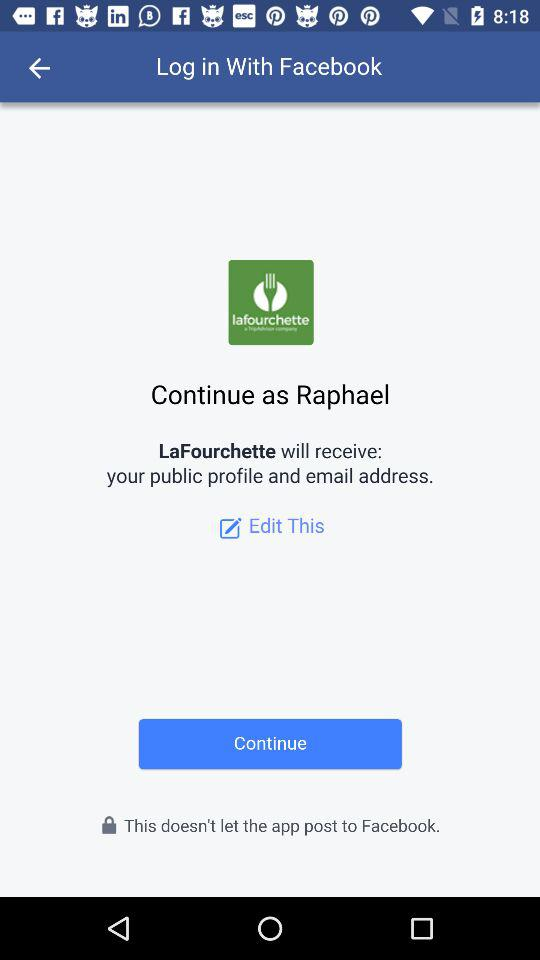What is the name of the user? The name of the user is Raphael. 